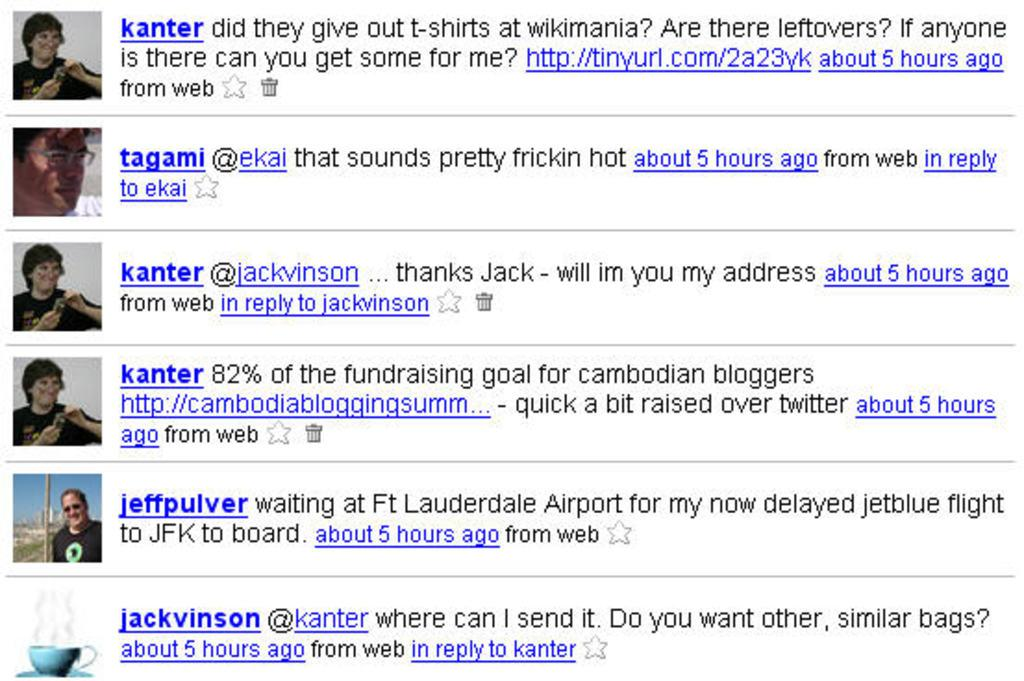What type of image is shown in the screenshot? The image is a screenshot of a Twitter account. What can be seen on the left side of the screenshot? There are profile photos of people on the left side of the image. What type of chair is visible in the image? There is no chair present in the image; it is a screenshot of a Twitter account with profile photos on the left side. 